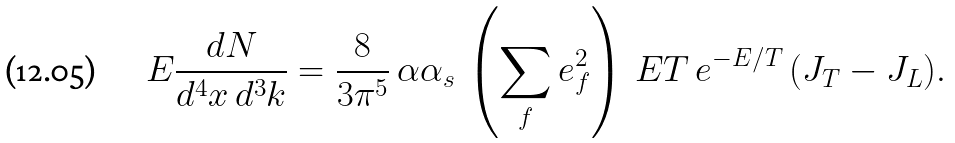Convert formula to latex. <formula><loc_0><loc_0><loc_500><loc_500>E \frac { d N } { d ^ { 4 } x \, d ^ { 3 } k } = \frac { 8 } { 3 \pi ^ { 5 } } \, \alpha \alpha _ { s } \, \left ( \sum _ { f } e _ { f } ^ { 2 } \right ) \, E T \, e ^ { - E / T } \, ( J _ { T } - J _ { L } ) .</formula> 